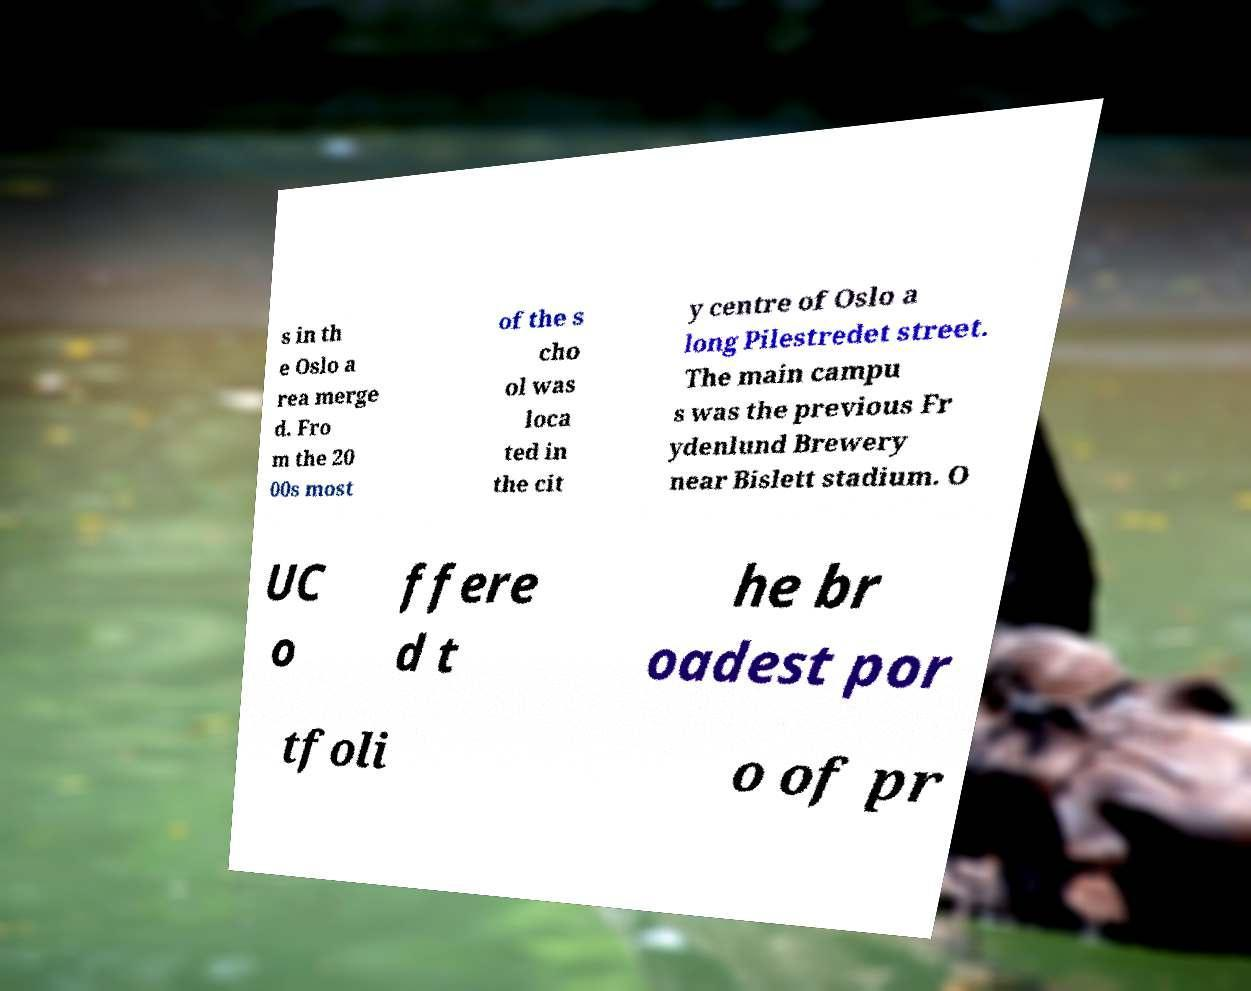Please identify and transcribe the text found in this image. s in th e Oslo a rea merge d. Fro m the 20 00s most of the s cho ol was loca ted in the cit y centre of Oslo a long Pilestredet street. The main campu s was the previous Fr ydenlund Brewery near Bislett stadium. O UC o ffere d t he br oadest por tfoli o of pr 